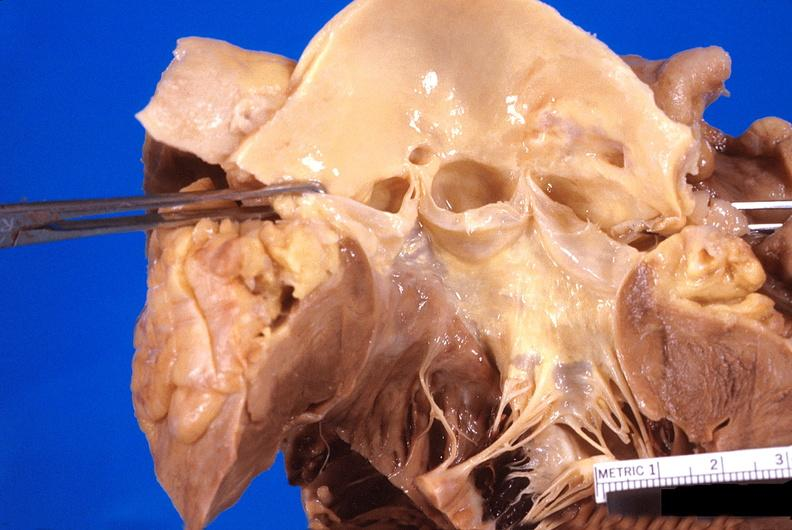where is this?
Answer the question using a single word or phrase. Heart 